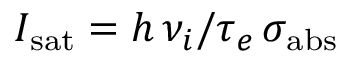<formula> <loc_0><loc_0><loc_500><loc_500>I _ { s a t } = h \, \nu _ { i } / \tau _ { e } \, \sigma _ { a b s }</formula> 